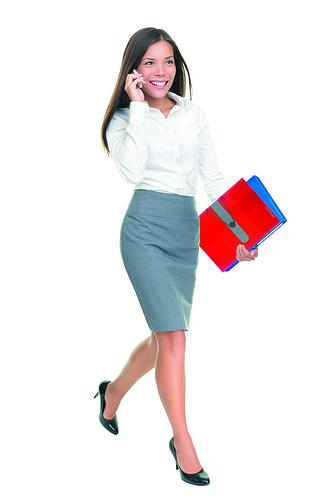Question: who is in the picture?
Choices:
A. Man.
B. Woman.
C. Boy.
D. Girl.
Answer with the letter. Answer: B Question: what type of picture is this?
Choices:
A. Wedding picture.
B. Advertisement.
C. Grainy picture.
D. Blurry picture.
Answer with the letter. Answer: B Question: why is she smiling?
Choices:
A. Laughing.
B. Happy.
C. A joke was said.
D. An amusing television show.
Answer with the letter. Answer: B Question: where is her folder?
Choices:
A. On the table.
B. On the desk.
C. In her hand.
D. On the dresser.
Answer with the letter. Answer: C Question: what color is the skirt?
Choices:
A. Light blue.
B. Mauve.
C. Red.
D. Green.
Answer with the letter. Answer: D 